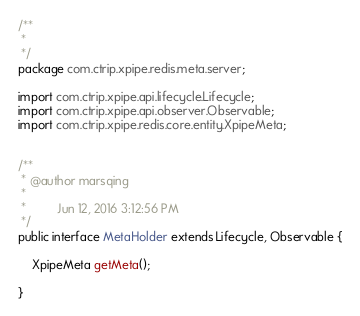<code> <loc_0><loc_0><loc_500><loc_500><_Java_>/**
 * 
 */
package com.ctrip.xpipe.redis.meta.server;

import com.ctrip.xpipe.api.lifecycle.Lifecycle;
import com.ctrip.xpipe.api.observer.Observable;
import com.ctrip.xpipe.redis.core.entity.XpipeMeta;


/**
 * @author marsqing
 *
 *         Jun 12, 2016 3:12:56 PM
 */
public interface MetaHolder extends Lifecycle, Observable {

	XpipeMeta getMeta();

}
</code> 